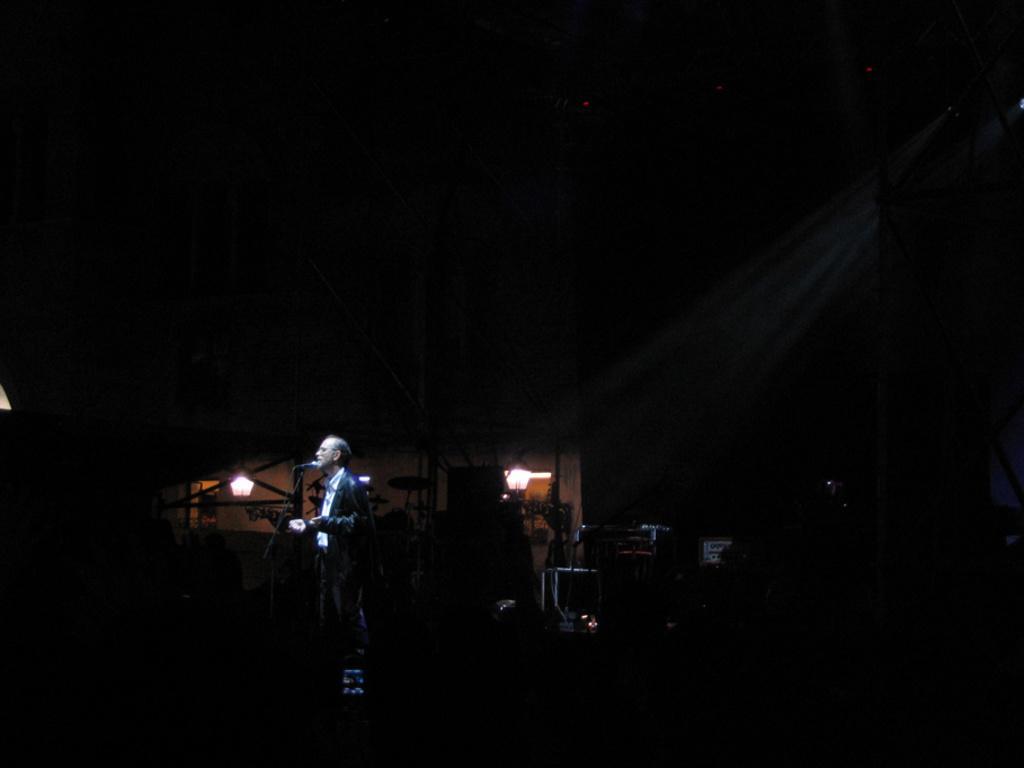Please provide a concise description of this image. In this image we can see a person wearing a suit. There is a mic. There are musical instruments. In the background of the image there are lights. 